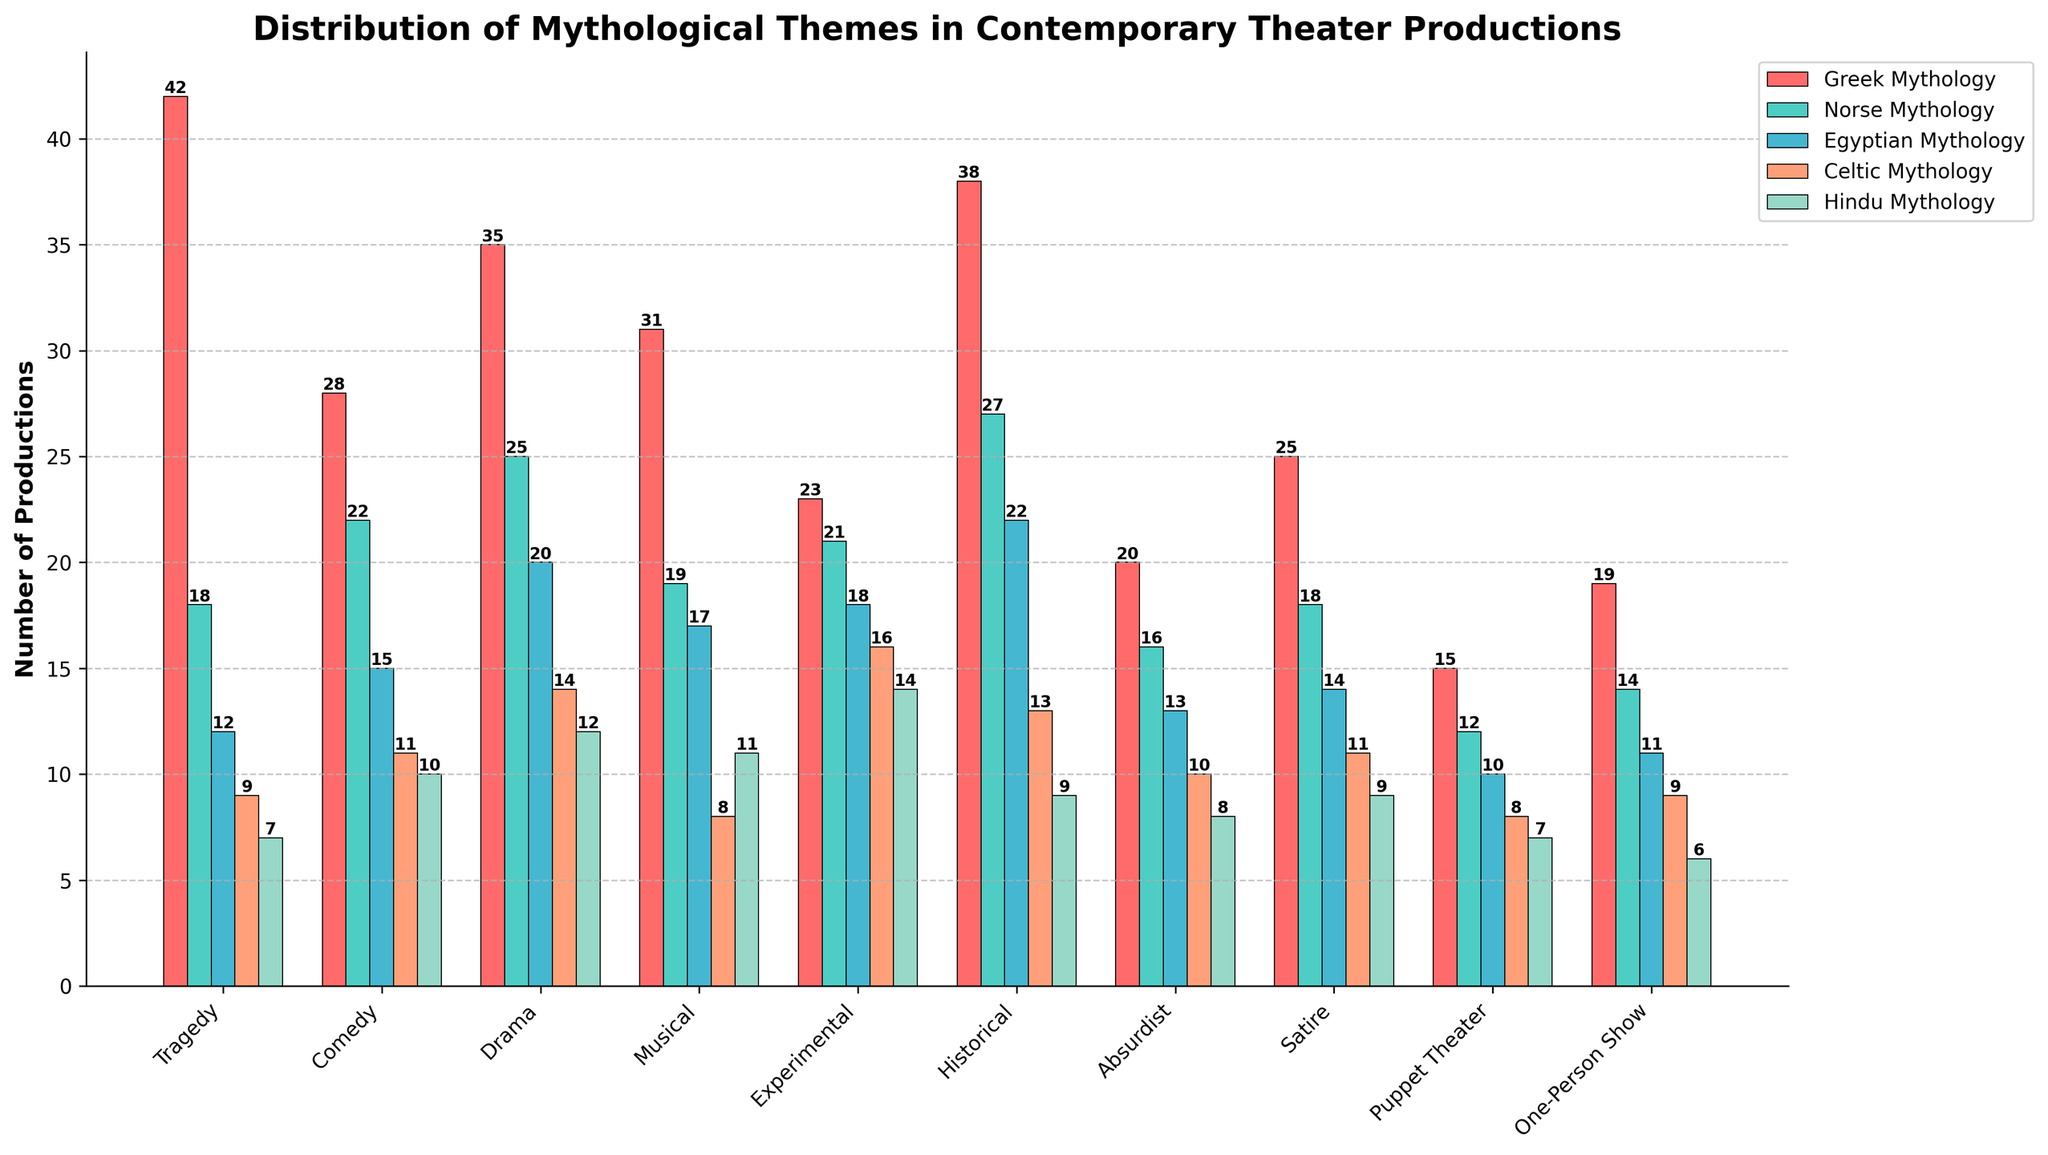What genre has the highest number of Greek Mythology productions? By looking at the height of the bars corresponding to 'Greek Mythology', the 'Tragedy' genre has the highest bar.
Answer: Tragedy How do Comedy and Drama compare in terms of Norse Mythology productions? Compare the heights of the bars for 'Norse Mythology' in both 'Comedy' and 'Drama'. Drama has a slightly taller bar.
Answer: Drama What is the total number of Egyptian Mythology productions across all genres? Sum the values for 'Egyptian Mythology' across all genres: 12 + 15 + 20 + 17 + 18 + 22 + 13 + 14 + 10 + 11 = 152.
Answer: 152 Which genre has a higher number of Celtic Mythology productions, Historical or Experimental? Compare the heights of the 'Celtic Mythology' bars for 'Historical' and 'Experimental'. Experimental has a higher bar.
Answer: Experimental Which mythology has the least representations in Puppet Theater? Look at the heights of the bars in the 'Puppet Theater' section. 'Hindu Mythology' has the shortest bar.
Answer: Hindu Mythology Compare the number of productions involving Greek Mythology between Musicals and Historical productions. Look at the heights of the 'Greek Mythology' bars for 'Musical' (31) and 'Historical' (38). Historical is higher.
Answer: Historical Which genre has the smallest number of productions for Hindu Mythology? Look at the heights of the 'Hindu Mythology' bars across all genres. 'One-Person Show' has the shortest bar.
Answer: One-Person Show How many mythologies have more than 20 representations in the Drama genre? Check the 'Drama' section for bars taller than 20. 'Greek Mythology' and 'Norse Mythology' (both over 20).
Answer: 2 What is the difference in number of Norse Mythology productions between Satire and Absurdist genres? Look at the heights of the 'Norse Mythology' bars for 'Satire' (18) and 'Absurdist' (16) and calculate the difference: 18 - 16 = 2.
Answer: 2 In which genre is the gap between Greek and Hindu Mythology productions the largest? Calculate the difference between 'Greek Mythology' and 'Hindu Mythology' for each genre. The largest gap is found in 'Tragedy' (42 - 7 = 35).
Answer: Tragedy 